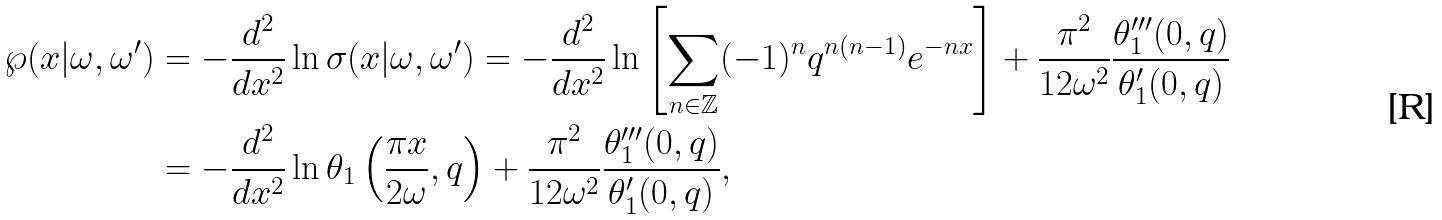Convert formula to latex. <formula><loc_0><loc_0><loc_500><loc_500>\wp ( x | \omega , \omega ^ { \prime } ) & = - \frac { d ^ { 2 } } { d x ^ { 2 } } \ln \sigma ( x | \omega , \omega ^ { \prime } ) = - \frac { d ^ { 2 } } { d x ^ { 2 } } \ln \left [ \sum _ { n \in \mathbb { Z } } ( - 1 ) ^ { n } q ^ { n ( n - 1 ) } e ^ { - n x } \right ] + \frac { \pi ^ { 2 } } { 1 2 \omega ^ { 2 } } \frac { \theta _ { 1 } ^ { \prime \prime \prime } ( 0 , q ) } { \theta _ { 1 } ^ { \prime } ( 0 , q ) } \\ & = - \frac { d ^ { 2 } } { d x ^ { 2 } } \ln \theta _ { 1 } \left ( \frac { \pi x } { 2 \omega } , q \right ) + \frac { \pi ^ { 2 } } { 1 2 \omega ^ { 2 } } \frac { \theta _ { 1 } ^ { \prime \prime \prime } ( 0 , q ) } { \theta _ { 1 } ^ { \prime } ( 0 , q ) } ,</formula> 